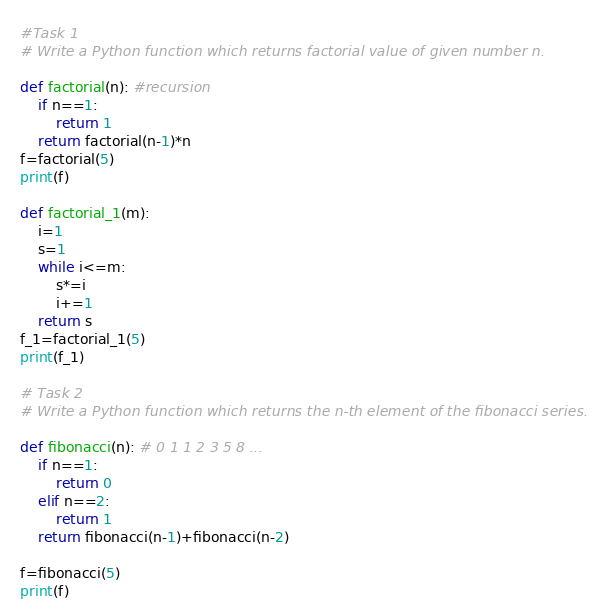<code> <loc_0><loc_0><loc_500><loc_500><_Python_>#Task 1
# Write a Python function which returns factorial value of given number n.

def factorial(n): #recursion
    if n==1:
        return 1
    return factorial(n-1)*n
f=factorial(5)
print(f)

def factorial_1(m):
    i=1
    s=1
    while i<=m:
        s*=i
        i+=1
    return s
f_1=factorial_1(5)
print(f_1)

# Task 2
# Write a Python function which returns the n-th element of the fibonacci series.

def fibonacci(n): # 0 1 1 2 3 5 8 ...
    if n==1:
        return 0
    elif n==2:
        return 1
    return fibonacci(n-1)+fibonacci(n-2)

f=fibonacci(5)
print(f)</code> 